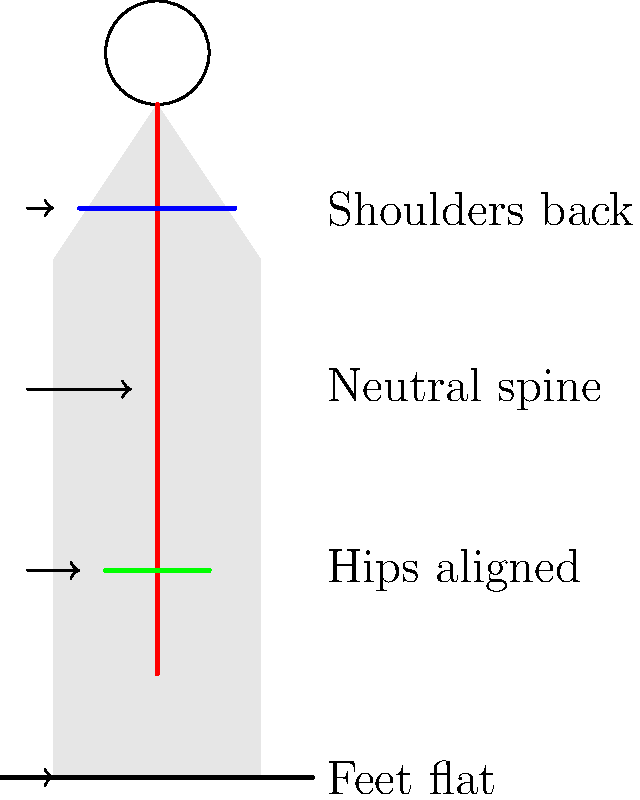In the diagram illustrating proper posture for long hours on set, which key elements are highlighted to maintain optimal biomechanics and reduce strain during extended periods of standing? The diagram highlights four key elements for maintaining proper posture during long hours on set:

1. Neutral spine: The red line in the diagram represents the spine. A neutral spine position is crucial for reducing stress on the back muscles and intervertebral discs. This means maintaining the natural curves of the spine without excessive arching or flattening.

2. Shoulders back: The blue line across the upper body represents the shoulders. Keeping the shoulders back and down helps to open up the chest, allowing for better breathing and reducing tension in the neck and upper back muscles.

3. Hips aligned: The green line across the lower body represents the hips. Proper hip alignment is essential for maintaining balance and reducing strain on the lower back. The hips should be level and facing forward.

4. Feet flat: The black line at the bottom represents the floor, with the label indicating that the feet should be flat. This provides a stable base of support and helps distribute weight evenly, reducing strain on the legs and back.

These elements work together to create an ergonomically sound posture that can be maintained for extended periods, reducing the risk of fatigue and injury during long hours on set.
Answer: Neutral spine, shoulders back, hips aligned, feet flat 